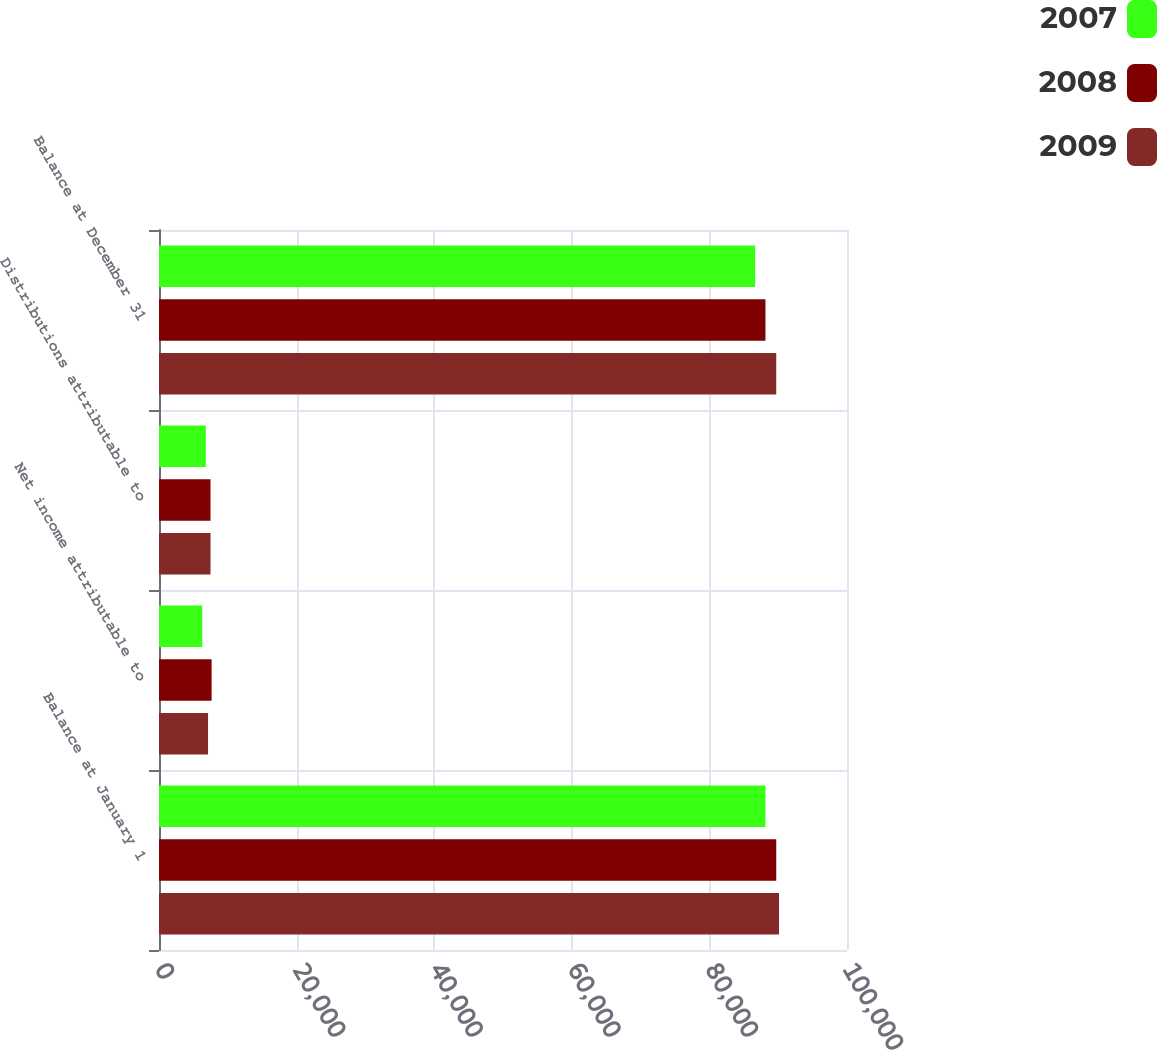Convert chart to OTSL. <chart><loc_0><loc_0><loc_500><loc_500><stacked_bar_chart><ecel><fcel>Balance at January 1<fcel>Net income attributable to<fcel>Distributions attributable to<fcel>Balance at December 31<nl><fcel>2007<fcel>88148<fcel>6288<fcel>6806<fcel>86656<nl><fcel>2008<fcel>89716<fcel>7646<fcel>7486<fcel>88148<nl><fcel>2009<fcel>90120<fcel>7128<fcel>7489<fcel>89716<nl></chart> 